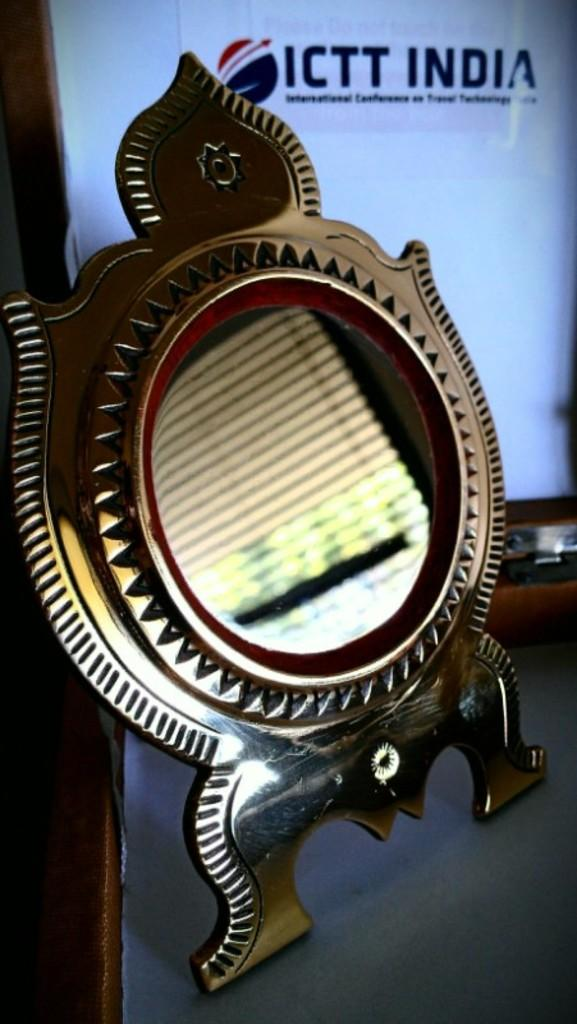What is the main object in the middle of the image? There is a mirror stand in the middle of the image. What can be seen in the background of the image? There is a poster and text in the background of the image. Can you see a partner working on a business project on a hill in the image? No, there is no partner, business project, or hill present in the image. 